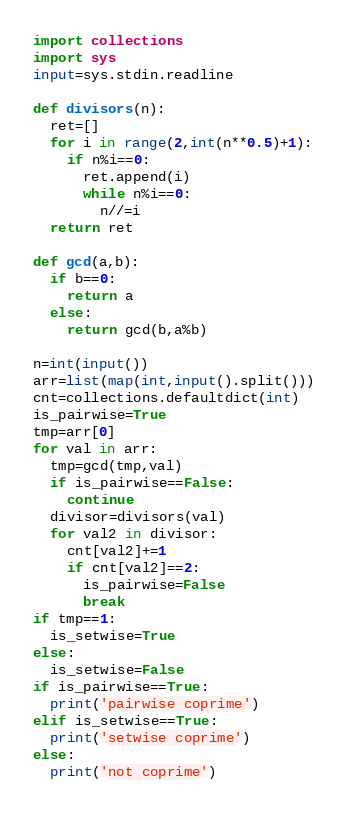<code> <loc_0><loc_0><loc_500><loc_500><_Python_>import collections
import sys
input=sys.stdin.readline

def divisors(n):
  ret=[]
  for i in range(2,int(n**0.5)+1):
    if n%i==0:
      ret.append(i)
      while n%i==0:
        n//=i
  return ret

def gcd(a,b):
  if b==0:
    return a
  else:
    return gcd(b,a%b)

n=int(input())
arr=list(map(int,input().split()))
cnt=collections.defaultdict(int)
is_pairwise=True
tmp=arr[0]
for val in arr:
  tmp=gcd(tmp,val)
  if is_pairwise==False:
    continue
  divisor=divisors(val)
  for val2 in divisor:
    cnt[val2]+=1
    if cnt[val2]==2:
      is_pairwise=False
      break
if tmp==1:
  is_setwise=True
else:
  is_setwise=False
if is_pairwise==True:
  print('pairwise coprime')
elif is_setwise==True:
  print('setwise coprime')
else:
  print('not coprime')</code> 